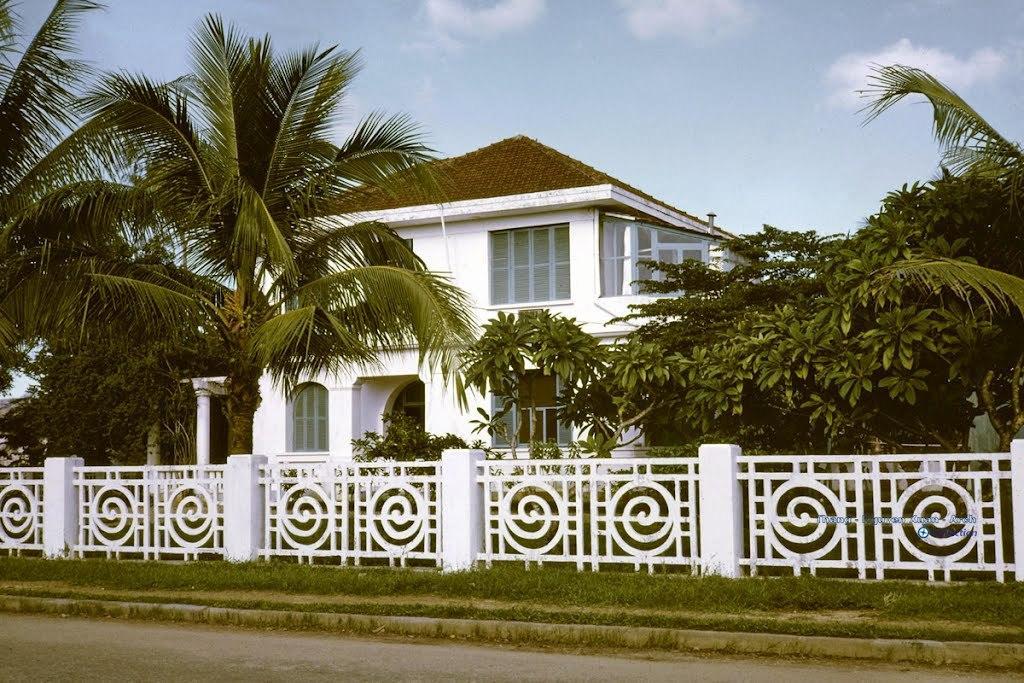Can you describe this image briefly? In this image we can see there is a building, in front of the building there are trees, fence, grass, road and sky in the background. 